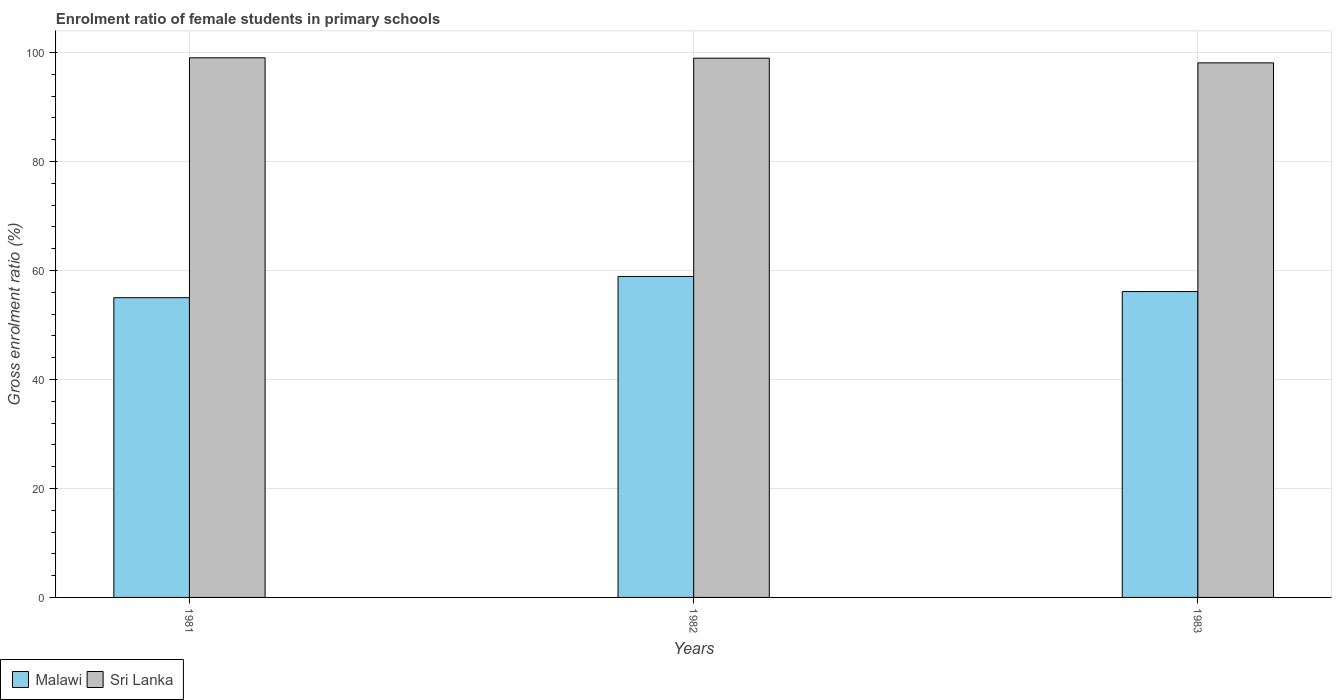In how many cases, is the number of bars for a given year not equal to the number of legend labels?
Your response must be concise. 0. What is the enrolment ratio of female students in primary schools in Sri Lanka in 1981?
Your response must be concise. 99.03. Across all years, what is the maximum enrolment ratio of female students in primary schools in Malawi?
Provide a succinct answer. 58.91. Across all years, what is the minimum enrolment ratio of female students in primary schools in Malawi?
Offer a terse response. 55. In which year was the enrolment ratio of female students in primary schools in Malawi minimum?
Give a very brief answer. 1981. What is the total enrolment ratio of female students in primary schools in Malawi in the graph?
Your answer should be compact. 170.05. What is the difference between the enrolment ratio of female students in primary schools in Malawi in 1982 and that in 1983?
Offer a very short reply. 2.77. What is the difference between the enrolment ratio of female students in primary schools in Sri Lanka in 1982 and the enrolment ratio of female students in primary schools in Malawi in 1983?
Your response must be concise. 42.83. What is the average enrolment ratio of female students in primary schools in Sri Lanka per year?
Offer a terse response. 98.7. In the year 1983, what is the difference between the enrolment ratio of female students in primary schools in Sri Lanka and enrolment ratio of female students in primary schools in Malawi?
Your answer should be compact. 41.97. What is the ratio of the enrolment ratio of female students in primary schools in Sri Lanka in 1982 to that in 1983?
Provide a succinct answer. 1.01. Is the difference between the enrolment ratio of female students in primary schools in Sri Lanka in 1981 and 1982 greater than the difference between the enrolment ratio of female students in primary schools in Malawi in 1981 and 1982?
Your answer should be compact. Yes. What is the difference between the highest and the second highest enrolment ratio of female students in primary schools in Sri Lanka?
Your answer should be very brief. 0.07. What is the difference between the highest and the lowest enrolment ratio of female students in primary schools in Malawi?
Provide a succinct answer. 3.9. Is the sum of the enrolment ratio of female students in primary schools in Sri Lanka in 1982 and 1983 greater than the maximum enrolment ratio of female students in primary schools in Malawi across all years?
Give a very brief answer. Yes. What does the 2nd bar from the left in 1983 represents?
Give a very brief answer. Sri Lanka. What does the 1st bar from the right in 1983 represents?
Make the answer very short. Sri Lanka. Are all the bars in the graph horizontal?
Keep it short and to the point. No. How many years are there in the graph?
Your answer should be very brief. 3. What is the difference between two consecutive major ticks on the Y-axis?
Your answer should be compact. 20. Where does the legend appear in the graph?
Your answer should be compact. Bottom left. How are the legend labels stacked?
Provide a succinct answer. Horizontal. What is the title of the graph?
Keep it short and to the point. Enrolment ratio of female students in primary schools. What is the label or title of the Y-axis?
Keep it short and to the point. Gross enrolment ratio (%). What is the Gross enrolment ratio (%) of Malawi in 1981?
Make the answer very short. 55. What is the Gross enrolment ratio (%) of Sri Lanka in 1981?
Your answer should be very brief. 99.03. What is the Gross enrolment ratio (%) of Malawi in 1982?
Make the answer very short. 58.91. What is the Gross enrolment ratio (%) in Sri Lanka in 1982?
Your response must be concise. 98.97. What is the Gross enrolment ratio (%) in Malawi in 1983?
Ensure brevity in your answer.  56.14. What is the Gross enrolment ratio (%) of Sri Lanka in 1983?
Your answer should be compact. 98.11. Across all years, what is the maximum Gross enrolment ratio (%) of Malawi?
Keep it short and to the point. 58.91. Across all years, what is the maximum Gross enrolment ratio (%) in Sri Lanka?
Provide a short and direct response. 99.03. Across all years, what is the minimum Gross enrolment ratio (%) of Malawi?
Offer a terse response. 55. Across all years, what is the minimum Gross enrolment ratio (%) of Sri Lanka?
Your answer should be compact. 98.11. What is the total Gross enrolment ratio (%) in Malawi in the graph?
Ensure brevity in your answer.  170.05. What is the total Gross enrolment ratio (%) of Sri Lanka in the graph?
Provide a short and direct response. 296.11. What is the difference between the Gross enrolment ratio (%) in Malawi in 1981 and that in 1982?
Ensure brevity in your answer.  -3.9. What is the difference between the Gross enrolment ratio (%) of Sri Lanka in 1981 and that in 1982?
Make the answer very short. 0.07. What is the difference between the Gross enrolment ratio (%) in Malawi in 1981 and that in 1983?
Your answer should be compact. -1.13. What is the difference between the Gross enrolment ratio (%) in Sri Lanka in 1981 and that in 1983?
Give a very brief answer. 0.92. What is the difference between the Gross enrolment ratio (%) in Malawi in 1982 and that in 1983?
Offer a very short reply. 2.77. What is the difference between the Gross enrolment ratio (%) of Sri Lanka in 1982 and that in 1983?
Your answer should be compact. 0.86. What is the difference between the Gross enrolment ratio (%) in Malawi in 1981 and the Gross enrolment ratio (%) in Sri Lanka in 1982?
Offer a very short reply. -43.96. What is the difference between the Gross enrolment ratio (%) in Malawi in 1981 and the Gross enrolment ratio (%) in Sri Lanka in 1983?
Make the answer very short. -43.11. What is the difference between the Gross enrolment ratio (%) of Malawi in 1982 and the Gross enrolment ratio (%) of Sri Lanka in 1983?
Offer a very short reply. -39.2. What is the average Gross enrolment ratio (%) in Malawi per year?
Keep it short and to the point. 56.68. What is the average Gross enrolment ratio (%) of Sri Lanka per year?
Ensure brevity in your answer.  98.7. In the year 1981, what is the difference between the Gross enrolment ratio (%) of Malawi and Gross enrolment ratio (%) of Sri Lanka?
Your response must be concise. -44.03. In the year 1982, what is the difference between the Gross enrolment ratio (%) of Malawi and Gross enrolment ratio (%) of Sri Lanka?
Ensure brevity in your answer.  -40.06. In the year 1983, what is the difference between the Gross enrolment ratio (%) of Malawi and Gross enrolment ratio (%) of Sri Lanka?
Give a very brief answer. -41.97. What is the ratio of the Gross enrolment ratio (%) in Malawi in 1981 to that in 1982?
Your response must be concise. 0.93. What is the ratio of the Gross enrolment ratio (%) of Malawi in 1981 to that in 1983?
Provide a succinct answer. 0.98. What is the ratio of the Gross enrolment ratio (%) in Sri Lanka in 1981 to that in 1983?
Make the answer very short. 1.01. What is the ratio of the Gross enrolment ratio (%) of Malawi in 1982 to that in 1983?
Offer a very short reply. 1.05. What is the ratio of the Gross enrolment ratio (%) in Sri Lanka in 1982 to that in 1983?
Your answer should be compact. 1.01. What is the difference between the highest and the second highest Gross enrolment ratio (%) in Malawi?
Provide a short and direct response. 2.77. What is the difference between the highest and the second highest Gross enrolment ratio (%) in Sri Lanka?
Your answer should be very brief. 0.07. What is the difference between the highest and the lowest Gross enrolment ratio (%) of Malawi?
Your answer should be very brief. 3.9. What is the difference between the highest and the lowest Gross enrolment ratio (%) in Sri Lanka?
Keep it short and to the point. 0.92. 